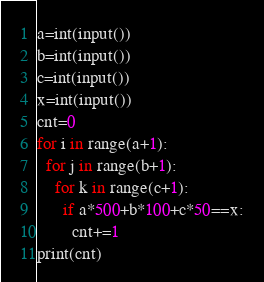<code> <loc_0><loc_0><loc_500><loc_500><_Python_>a=int(input())
b=int(input())
c=int(input())
x=int(input())
cnt=0
for i in range(a+1):
  for j in range(b+1):
    for k in range(c+1):
      if a*500+b*100+c*50==x:
        cnt+=1
print(cnt)</code> 